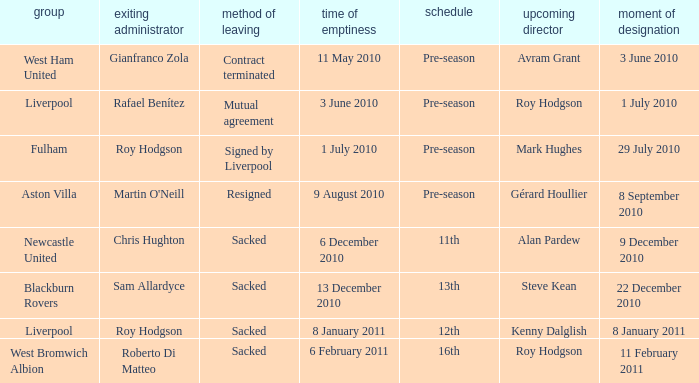What is the date of vacancy for the Liverpool team with a table named pre-season? 3 June 2010. 